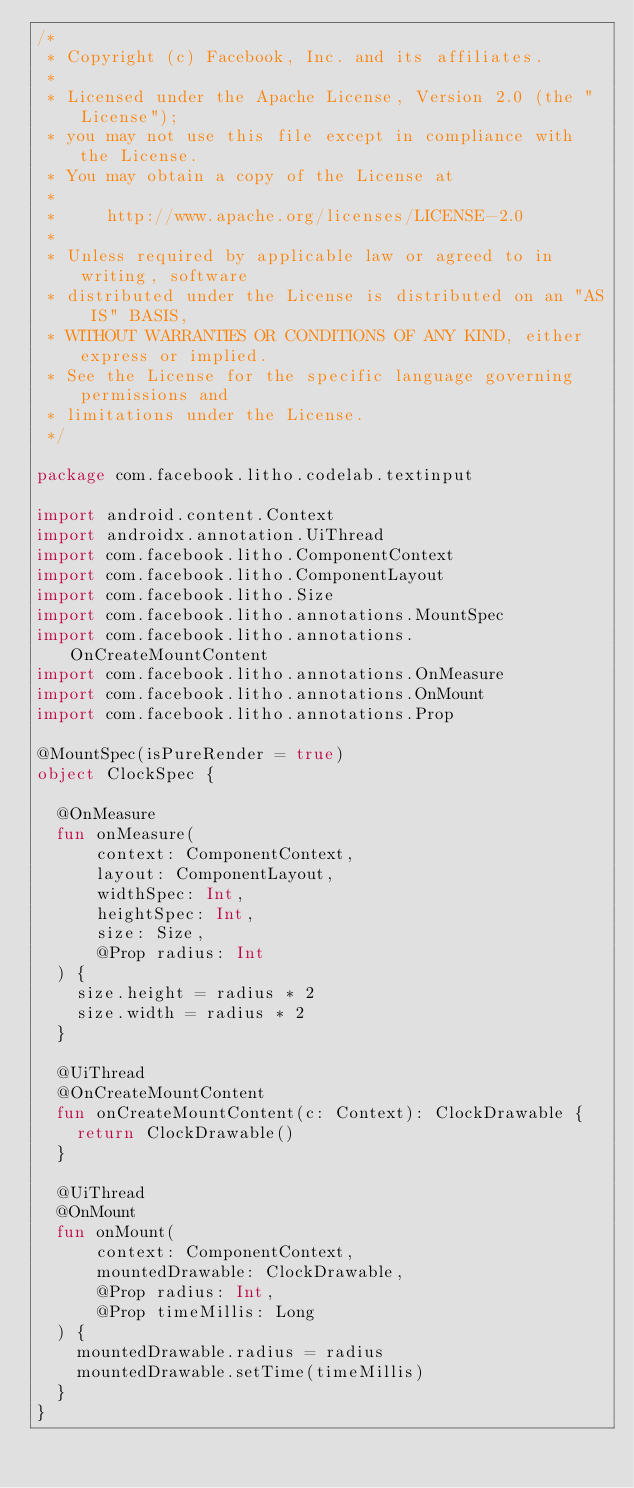Convert code to text. <code><loc_0><loc_0><loc_500><loc_500><_Kotlin_>/*
 * Copyright (c) Facebook, Inc. and its affiliates.
 *
 * Licensed under the Apache License, Version 2.0 (the "License");
 * you may not use this file except in compliance with the License.
 * You may obtain a copy of the License at
 *
 *     http://www.apache.org/licenses/LICENSE-2.0
 *
 * Unless required by applicable law or agreed to in writing, software
 * distributed under the License is distributed on an "AS IS" BASIS,
 * WITHOUT WARRANTIES OR CONDITIONS OF ANY KIND, either express or implied.
 * See the License for the specific language governing permissions and
 * limitations under the License.
 */

package com.facebook.litho.codelab.textinput

import android.content.Context
import androidx.annotation.UiThread
import com.facebook.litho.ComponentContext
import com.facebook.litho.ComponentLayout
import com.facebook.litho.Size
import com.facebook.litho.annotations.MountSpec
import com.facebook.litho.annotations.OnCreateMountContent
import com.facebook.litho.annotations.OnMeasure
import com.facebook.litho.annotations.OnMount
import com.facebook.litho.annotations.Prop

@MountSpec(isPureRender = true)
object ClockSpec {

  @OnMeasure
  fun onMeasure(
      context: ComponentContext,
      layout: ComponentLayout,
      widthSpec: Int,
      heightSpec: Int,
      size: Size,
      @Prop radius: Int
  ) {
    size.height = radius * 2
    size.width = radius * 2
  }

  @UiThread
  @OnCreateMountContent
  fun onCreateMountContent(c: Context): ClockDrawable {
    return ClockDrawable()
  }

  @UiThread
  @OnMount
  fun onMount(
      context: ComponentContext,
      mountedDrawable: ClockDrawable,
      @Prop radius: Int,
      @Prop timeMillis: Long
  ) {
    mountedDrawable.radius = radius
    mountedDrawable.setTime(timeMillis)
  }
}
</code> 